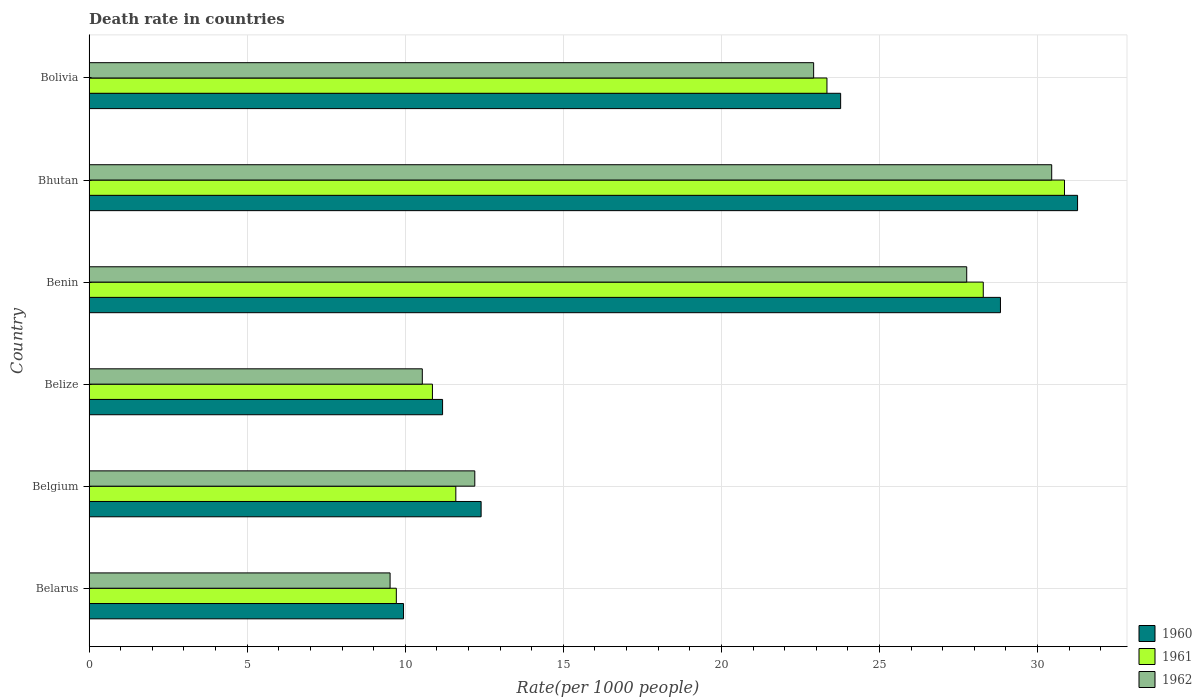How many different coloured bars are there?
Keep it short and to the point. 3. How many groups of bars are there?
Ensure brevity in your answer.  6. How many bars are there on the 6th tick from the bottom?
Your answer should be compact. 3. What is the label of the 5th group of bars from the top?
Offer a very short reply. Belgium. What is the death rate in 1961 in Bhutan?
Keep it short and to the point. 30.85. Across all countries, what is the maximum death rate in 1961?
Your answer should be very brief. 30.85. Across all countries, what is the minimum death rate in 1961?
Give a very brief answer. 9.72. In which country was the death rate in 1960 maximum?
Your answer should be compact. Bhutan. In which country was the death rate in 1960 minimum?
Provide a short and direct response. Belarus. What is the total death rate in 1960 in the graph?
Keep it short and to the point. 117.39. What is the difference between the death rate in 1961 in Belize and that in Bolivia?
Keep it short and to the point. -12.48. What is the difference between the death rate in 1961 in Belize and the death rate in 1960 in Belgium?
Offer a very short reply. -1.54. What is the average death rate in 1961 per country?
Ensure brevity in your answer.  19.11. What is the difference between the death rate in 1960 and death rate in 1962 in Belgium?
Offer a terse response. 0.2. What is the ratio of the death rate in 1960 in Benin to that in Bolivia?
Keep it short and to the point. 1.21. Is the death rate in 1960 in Benin less than that in Bhutan?
Your answer should be very brief. Yes. What is the difference between the highest and the second highest death rate in 1962?
Ensure brevity in your answer.  2.69. What is the difference between the highest and the lowest death rate in 1960?
Your answer should be compact. 21.32. In how many countries, is the death rate in 1962 greater than the average death rate in 1962 taken over all countries?
Your answer should be compact. 3. What does the 1st bar from the top in Bhutan represents?
Make the answer very short. 1962. What does the 3rd bar from the bottom in Bolivia represents?
Provide a short and direct response. 1962. What is the difference between two consecutive major ticks on the X-axis?
Offer a very short reply. 5. Are the values on the major ticks of X-axis written in scientific E-notation?
Provide a succinct answer. No. Does the graph contain grids?
Make the answer very short. Yes. How many legend labels are there?
Your response must be concise. 3. What is the title of the graph?
Your answer should be very brief. Death rate in countries. What is the label or title of the X-axis?
Give a very brief answer. Rate(per 1000 people). What is the label or title of the Y-axis?
Provide a short and direct response. Country. What is the Rate(per 1000 people) in 1960 in Belarus?
Your answer should be compact. 9.95. What is the Rate(per 1000 people) in 1961 in Belarus?
Offer a terse response. 9.72. What is the Rate(per 1000 people) of 1962 in Belarus?
Provide a succinct answer. 9.52. What is the Rate(per 1000 people) of 1960 in Belgium?
Ensure brevity in your answer.  12.4. What is the Rate(per 1000 people) of 1962 in Belgium?
Your response must be concise. 12.2. What is the Rate(per 1000 people) of 1960 in Belize?
Your response must be concise. 11.18. What is the Rate(per 1000 people) in 1961 in Belize?
Ensure brevity in your answer.  10.86. What is the Rate(per 1000 people) in 1962 in Belize?
Provide a short and direct response. 10.54. What is the Rate(per 1000 people) of 1960 in Benin?
Offer a very short reply. 28.83. What is the Rate(per 1000 people) of 1961 in Benin?
Offer a terse response. 28.28. What is the Rate(per 1000 people) of 1962 in Benin?
Keep it short and to the point. 27.76. What is the Rate(per 1000 people) of 1960 in Bhutan?
Offer a very short reply. 31.27. What is the Rate(per 1000 people) of 1961 in Bhutan?
Provide a succinct answer. 30.85. What is the Rate(per 1000 people) in 1962 in Bhutan?
Give a very brief answer. 30.45. What is the Rate(per 1000 people) of 1960 in Bolivia?
Make the answer very short. 23.77. What is the Rate(per 1000 people) in 1961 in Bolivia?
Make the answer very short. 23.34. What is the Rate(per 1000 people) of 1962 in Bolivia?
Keep it short and to the point. 22.92. Across all countries, what is the maximum Rate(per 1000 people) in 1960?
Provide a succinct answer. 31.27. Across all countries, what is the maximum Rate(per 1000 people) in 1961?
Keep it short and to the point. 30.85. Across all countries, what is the maximum Rate(per 1000 people) of 1962?
Your answer should be very brief. 30.45. Across all countries, what is the minimum Rate(per 1000 people) of 1960?
Provide a short and direct response. 9.95. Across all countries, what is the minimum Rate(per 1000 people) in 1961?
Provide a succinct answer. 9.72. Across all countries, what is the minimum Rate(per 1000 people) in 1962?
Provide a succinct answer. 9.52. What is the total Rate(per 1000 people) in 1960 in the graph?
Give a very brief answer. 117.39. What is the total Rate(per 1000 people) of 1961 in the graph?
Make the answer very short. 114.65. What is the total Rate(per 1000 people) of 1962 in the graph?
Ensure brevity in your answer.  113.39. What is the difference between the Rate(per 1000 people) of 1960 in Belarus and that in Belgium?
Your response must be concise. -2.45. What is the difference between the Rate(per 1000 people) in 1961 in Belarus and that in Belgium?
Keep it short and to the point. -1.88. What is the difference between the Rate(per 1000 people) of 1962 in Belarus and that in Belgium?
Provide a short and direct response. -2.68. What is the difference between the Rate(per 1000 people) of 1960 in Belarus and that in Belize?
Your answer should be compact. -1.24. What is the difference between the Rate(per 1000 people) of 1961 in Belarus and that in Belize?
Make the answer very short. -1.14. What is the difference between the Rate(per 1000 people) of 1962 in Belarus and that in Belize?
Give a very brief answer. -1.02. What is the difference between the Rate(per 1000 people) of 1960 in Belarus and that in Benin?
Keep it short and to the point. -18.88. What is the difference between the Rate(per 1000 people) of 1961 in Belarus and that in Benin?
Your response must be concise. -18.57. What is the difference between the Rate(per 1000 people) in 1962 in Belarus and that in Benin?
Your answer should be compact. -18.24. What is the difference between the Rate(per 1000 people) of 1960 in Belarus and that in Bhutan?
Keep it short and to the point. -21.32. What is the difference between the Rate(per 1000 people) in 1961 in Belarus and that in Bhutan?
Offer a very short reply. -21.13. What is the difference between the Rate(per 1000 people) of 1962 in Belarus and that in Bhutan?
Provide a short and direct response. -20.93. What is the difference between the Rate(per 1000 people) in 1960 in Belarus and that in Bolivia?
Provide a short and direct response. -13.83. What is the difference between the Rate(per 1000 people) in 1961 in Belarus and that in Bolivia?
Provide a succinct answer. -13.62. What is the difference between the Rate(per 1000 people) of 1962 in Belarus and that in Bolivia?
Provide a succinct answer. -13.4. What is the difference between the Rate(per 1000 people) of 1960 in Belgium and that in Belize?
Provide a succinct answer. 1.22. What is the difference between the Rate(per 1000 people) in 1961 in Belgium and that in Belize?
Your answer should be very brief. 0.74. What is the difference between the Rate(per 1000 people) of 1962 in Belgium and that in Belize?
Ensure brevity in your answer.  1.66. What is the difference between the Rate(per 1000 people) of 1960 in Belgium and that in Benin?
Offer a terse response. -16.43. What is the difference between the Rate(per 1000 people) of 1961 in Belgium and that in Benin?
Ensure brevity in your answer.  -16.68. What is the difference between the Rate(per 1000 people) of 1962 in Belgium and that in Benin?
Your response must be concise. -15.56. What is the difference between the Rate(per 1000 people) of 1960 in Belgium and that in Bhutan?
Your answer should be very brief. -18.87. What is the difference between the Rate(per 1000 people) of 1961 in Belgium and that in Bhutan?
Provide a short and direct response. -19.25. What is the difference between the Rate(per 1000 people) in 1962 in Belgium and that in Bhutan?
Make the answer very short. -18.25. What is the difference between the Rate(per 1000 people) of 1960 in Belgium and that in Bolivia?
Your answer should be very brief. -11.37. What is the difference between the Rate(per 1000 people) in 1961 in Belgium and that in Bolivia?
Offer a terse response. -11.74. What is the difference between the Rate(per 1000 people) in 1962 in Belgium and that in Bolivia?
Offer a terse response. -10.72. What is the difference between the Rate(per 1000 people) of 1960 in Belize and that in Benin?
Give a very brief answer. -17.65. What is the difference between the Rate(per 1000 people) in 1961 in Belize and that in Benin?
Provide a succinct answer. -17.42. What is the difference between the Rate(per 1000 people) in 1962 in Belize and that in Benin?
Your response must be concise. -17.22. What is the difference between the Rate(per 1000 people) in 1960 in Belize and that in Bhutan?
Provide a succinct answer. -20.09. What is the difference between the Rate(per 1000 people) in 1961 in Belize and that in Bhutan?
Give a very brief answer. -19.99. What is the difference between the Rate(per 1000 people) of 1962 in Belize and that in Bhutan?
Provide a short and direct response. -19.91. What is the difference between the Rate(per 1000 people) of 1960 in Belize and that in Bolivia?
Give a very brief answer. -12.59. What is the difference between the Rate(per 1000 people) in 1961 in Belize and that in Bolivia?
Provide a short and direct response. -12.48. What is the difference between the Rate(per 1000 people) of 1962 in Belize and that in Bolivia?
Your response must be concise. -12.38. What is the difference between the Rate(per 1000 people) of 1960 in Benin and that in Bhutan?
Your answer should be compact. -2.44. What is the difference between the Rate(per 1000 people) in 1961 in Benin and that in Bhutan?
Your response must be concise. -2.57. What is the difference between the Rate(per 1000 people) in 1962 in Benin and that in Bhutan?
Provide a short and direct response. -2.69. What is the difference between the Rate(per 1000 people) in 1960 in Benin and that in Bolivia?
Give a very brief answer. 5.05. What is the difference between the Rate(per 1000 people) in 1961 in Benin and that in Bolivia?
Your answer should be compact. 4.94. What is the difference between the Rate(per 1000 people) in 1962 in Benin and that in Bolivia?
Provide a short and direct response. 4.84. What is the difference between the Rate(per 1000 people) of 1960 in Bhutan and that in Bolivia?
Keep it short and to the point. 7.49. What is the difference between the Rate(per 1000 people) of 1961 in Bhutan and that in Bolivia?
Your answer should be compact. 7.51. What is the difference between the Rate(per 1000 people) of 1962 in Bhutan and that in Bolivia?
Make the answer very short. 7.53. What is the difference between the Rate(per 1000 people) in 1960 in Belarus and the Rate(per 1000 people) in 1961 in Belgium?
Provide a succinct answer. -1.65. What is the difference between the Rate(per 1000 people) in 1960 in Belarus and the Rate(per 1000 people) in 1962 in Belgium?
Offer a terse response. -2.25. What is the difference between the Rate(per 1000 people) in 1961 in Belarus and the Rate(per 1000 people) in 1962 in Belgium?
Offer a very short reply. -2.48. What is the difference between the Rate(per 1000 people) in 1960 in Belarus and the Rate(per 1000 people) in 1961 in Belize?
Your answer should be very brief. -0.91. What is the difference between the Rate(per 1000 people) in 1960 in Belarus and the Rate(per 1000 people) in 1962 in Belize?
Offer a terse response. -0.59. What is the difference between the Rate(per 1000 people) in 1961 in Belarus and the Rate(per 1000 people) in 1962 in Belize?
Your answer should be very brief. -0.82. What is the difference between the Rate(per 1000 people) in 1960 in Belarus and the Rate(per 1000 people) in 1961 in Benin?
Ensure brevity in your answer.  -18.34. What is the difference between the Rate(per 1000 people) of 1960 in Belarus and the Rate(per 1000 people) of 1962 in Benin?
Ensure brevity in your answer.  -17.81. What is the difference between the Rate(per 1000 people) in 1961 in Belarus and the Rate(per 1000 people) in 1962 in Benin?
Provide a short and direct response. -18.04. What is the difference between the Rate(per 1000 people) of 1960 in Belarus and the Rate(per 1000 people) of 1961 in Bhutan?
Your answer should be very brief. -20.91. What is the difference between the Rate(per 1000 people) of 1960 in Belarus and the Rate(per 1000 people) of 1962 in Bhutan?
Your answer should be compact. -20.5. What is the difference between the Rate(per 1000 people) in 1961 in Belarus and the Rate(per 1000 people) in 1962 in Bhutan?
Provide a short and direct response. -20.73. What is the difference between the Rate(per 1000 people) in 1960 in Belarus and the Rate(per 1000 people) in 1961 in Bolivia?
Keep it short and to the point. -13.39. What is the difference between the Rate(per 1000 people) of 1960 in Belarus and the Rate(per 1000 people) of 1962 in Bolivia?
Provide a succinct answer. -12.97. What is the difference between the Rate(per 1000 people) of 1960 in Belgium and the Rate(per 1000 people) of 1961 in Belize?
Provide a short and direct response. 1.54. What is the difference between the Rate(per 1000 people) in 1960 in Belgium and the Rate(per 1000 people) in 1962 in Belize?
Keep it short and to the point. 1.86. What is the difference between the Rate(per 1000 people) of 1961 in Belgium and the Rate(per 1000 people) of 1962 in Belize?
Your answer should be compact. 1.06. What is the difference between the Rate(per 1000 people) in 1960 in Belgium and the Rate(per 1000 people) in 1961 in Benin?
Your answer should be compact. -15.88. What is the difference between the Rate(per 1000 people) in 1960 in Belgium and the Rate(per 1000 people) in 1962 in Benin?
Your answer should be compact. -15.36. What is the difference between the Rate(per 1000 people) of 1961 in Belgium and the Rate(per 1000 people) of 1962 in Benin?
Ensure brevity in your answer.  -16.16. What is the difference between the Rate(per 1000 people) in 1960 in Belgium and the Rate(per 1000 people) in 1961 in Bhutan?
Offer a very short reply. -18.45. What is the difference between the Rate(per 1000 people) of 1960 in Belgium and the Rate(per 1000 people) of 1962 in Bhutan?
Your response must be concise. -18.05. What is the difference between the Rate(per 1000 people) of 1961 in Belgium and the Rate(per 1000 people) of 1962 in Bhutan?
Your answer should be very brief. -18.85. What is the difference between the Rate(per 1000 people) in 1960 in Belgium and the Rate(per 1000 people) in 1961 in Bolivia?
Provide a succinct answer. -10.94. What is the difference between the Rate(per 1000 people) in 1960 in Belgium and the Rate(per 1000 people) in 1962 in Bolivia?
Keep it short and to the point. -10.52. What is the difference between the Rate(per 1000 people) in 1961 in Belgium and the Rate(per 1000 people) in 1962 in Bolivia?
Offer a very short reply. -11.32. What is the difference between the Rate(per 1000 people) in 1960 in Belize and the Rate(per 1000 people) in 1961 in Benin?
Provide a short and direct response. -17.1. What is the difference between the Rate(per 1000 people) of 1960 in Belize and the Rate(per 1000 people) of 1962 in Benin?
Give a very brief answer. -16.58. What is the difference between the Rate(per 1000 people) in 1961 in Belize and the Rate(per 1000 people) in 1962 in Benin?
Make the answer very short. -16.9. What is the difference between the Rate(per 1000 people) in 1960 in Belize and the Rate(per 1000 people) in 1961 in Bhutan?
Your response must be concise. -19.67. What is the difference between the Rate(per 1000 people) in 1960 in Belize and the Rate(per 1000 people) in 1962 in Bhutan?
Your answer should be compact. -19.27. What is the difference between the Rate(per 1000 people) in 1961 in Belize and the Rate(per 1000 people) in 1962 in Bhutan?
Your answer should be very brief. -19.59. What is the difference between the Rate(per 1000 people) in 1960 in Belize and the Rate(per 1000 people) in 1961 in Bolivia?
Provide a short and direct response. -12.16. What is the difference between the Rate(per 1000 people) in 1960 in Belize and the Rate(per 1000 people) in 1962 in Bolivia?
Offer a terse response. -11.74. What is the difference between the Rate(per 1000 people) of 1961 in Belize and the Rate(per 1000 people) of 1962 in Bolivia?
Ensure brevity in your answer.  -12.06. What is the difference between the Rate(per 1000 people) of 1960 in Benin and the Rate(per 1000 people) of 1961 in Bhutan?
Provide a short and direct response. -2.02. What is the difference between the Rate(per 1000 people) in 1960 in Benin and the Rate(per 1000 people) in 1962 in Bhutan?
Make the answer very short. -1.62. What is the difference between the Rate(per 1000 people) of 1961 in Benin and the Rate(per 1000 people) of 1962 in Bhutan?
Offer a terse response. -2.17. What is the difference between the Rate(per 1000 people) in 1960 in Benin and the Rate(per 1000 people) in 1961 in Bolivia?
Offer a very short reply. 5.49. What is the difference between the Rate(per 1000 people) in 1960 in Benin and the Rate(per 1000 people) in 1962 in Bolivia?
Ensure brevity in your answer.  5.91. What is the difference between the Rate(per 1000 people) of 1961 in Benin and the Rate(per 1000 people) of 1962 in Bolivia?
Offer a very short reply. 5.37. What is the difference between the Rate(per 1000 people) in 1960 in Bhutan and the Rate(per 1000 people) in 1961 in Bolivia?
Provide a short and direct response. 7.93. What is the difference between the Rate(per 1000 people) in 1960 in Bhutan and the Rate(per 1000 people) in 1962 in Bolivia?
Make the answer very short. 8.35. What is the difference between the Rate(per 1000 people) in 1961 in Bhutan and the Rate(per 1000 people) in 1962 in Bolivia?
Ensure brevity in your answer.  7.93. What is the average Rate(per 1000 people) in 1960 per country?
Offer a terse response. 19.57. What is the average Rate(per 1000 people) of 1961 per country?
Provide a succinct answer. 19.11. What is the average Rate(per 1000 people) of 1962 per country?
Make the answer very short. 18.9. What is the difference between the Rate(per 1000 people) of 1960 and Rate(per 1000 people) of 1961 in Belarus?
Provide a succinct answer. 0.23. What is the difference between the Rate(per 1000 people) in 1960 and Rate(per 1000 people) in 1962 in Belarus?
Offer a very short reply. 0.42. What is the difference between the Rate(per 1000 people) in 1961 and Rate(per 1000 people) in 1962 in Belarus?
Your response must be concise. 0.2. What is the difference between the Rate(per 1000 people) in 1960 and Rate(per 1000 people) in 1962 in Belgium?
Give a very brief answer. 0.2. What is the difference between the Rate(per 1000 people) in 1960 and Rate(per 1000 people) in 1961 in Belize?
Keep it short and to the point. 0.32. What is the difference between the Rate(per 1000 people) of 1960 and Rate(per 1000 people) of 1962 in Belize?
Ensure brevity in your answer.  0.64. What is the difference between the Rate(per 1000 people) in 1961 and Rate(per 1000 people) in 1962 in Belize?
Your response must be concise. 0.32. What is the difference between the Rate(per 1000 people) in 1960 and Rate(per 1000 people) in 1961 in Benin?
Your answer should be compact. 0.54. What is the difference between the Rate(per 1000 people) of 1960 and Rate(per 1000 people) of 1962 in Benin?
Keep it short and to the point. 1.07. What is the difference between the Rate(per 1000 people) in 1961 and Rate(per 1000 people) in 1962 in Benin?
Your answer should be very brief. 0.52. What is the difference between the Rate(per 1000 people) in 1960 and Rate(per 1000 people) in 1961 in Bhutan?
Make the answer very short. 0.41. What is the difference between the Rate(per 1000 people) of 1960 and Rate(per 1000 people) of 1962 in Bhutan?
Your answer should be compact. 0.82. What is the difference between the Rate(per 1000 people) in 1961 and Rate(per 1000 people) in 1962 in Bhutan?
Offer a very short reply. 0.4. What is the difference between the Rate(per 1000 people) in 1960 and Rate(per 1000 people) in 1961 in Bolivia?
Offer a very short reply. 0.43. What is the difference between the Rate(per 1000 people) of 1960 and Rate(per 1000 people) of 1962 in Bolivia?
Provide a short and direct response. 0.85. What is the difference between the Rate(per 1000 people) in 1961 and Rate(per 1000 people) in 1962 in Bolivia?
Offer a very short reply. 0.42. What is the ratio of the Rate(per 1000 people) of 1960 in Belarus to that in Belgium?
Keep it short and to the point. 0.8. What is the ratio of the Rate(per 1000 people) in 1961 in Belarus to that in Belgium?
Make the answer very short. 0.84. What is the ratio of the Rate(per 1000 people) of 1962 in Belarus to that in Belgium?
Your response must be concise. 0.78. What is the ratio of the Rate(per 1000 people) of 1960 in Belarus to that in Belize?
Your answer should be compact. 0.89. What is the ratio of the Rate(per 1000 people) in 1961 in Belarus to that in Belize?
Provide a short and direct response. 0.89. What is the ratio of the Rate(per 1000 people) in 1962 in Belarus to that in Belize?
Offer a terse response. 0.9. What is the ratio of the Rate(per 1000 people) of 1960 in Belarus to that in Benin?
Your answer should be compact. 0.34. What is the ratio of the Rate(per 1000 people) of 1961 in Belarus to that in Benin?
Ensure brevity in your answer.  0.34. What is the ratio of the Rate(per 1000 people) in 1962 in Belarus to that in Benin?
Ensure brevity in your answer.  0.34. What is the ratio of the Rate(per 1000 people) of 1960 in Belarus to that in Bhutan?
Provide a short and direct response. 0.32. What is the ratio of the Rate(per 1000 people) of 1961 in Belarus to that in Bhutan?
Ensure brevity in your answer.  0.32. What is the ratio of the Rate(per 1000 people) in 1962 in Belarus to that in Bhutan?
Offer a very short reply. 0.31. What is the ratio of the Rate(per 1000 people) of 1960 in Belarus to that in Bolivia?
Keep it short and to the point. 0.42. What is the ratio of the Rate(per 1000 people) in 1961 in Belarus to that in Bolivia?
Make the answer very short. 0.42. What is the ratio of the Rate(per 1000 people) of 1962 in Belarus to that in Bolivia?
Your response must be concise. 0.42. What is the ratio of the Rate(per 1000 people) of 1960 in Belgium to that in Belize?
Give a very brief answer. 1.11. What is the ratio of the Rate(per 1000 people) in 1961 in Belgium to that in Belize?
Give a very brief answer. 1.07. What is the ratio of the Rate(per 1000 people) of 1962 in Belgium to that in Belize?
Offer a very short reply. 1.16. What is the ratio of the Rate(per 1000 people) in 1960 in Belgium to that in Benin?
Provide a short and direct response. 0.43. What is the ratio of the Rate(per 1000 people) in 1961 in Belgium to that in Benin?
Provide a succinct answer. 0.41. What is the ratio of the Rate(per 1000 people) in 1962 in Belgium to that in Benin?
Offer a very short reply. 0.44. What is the ratio of the Rate(per 1000 people) of 1960 in Belgium to that in Bhutan?
Your answer should be very brief. 0.4. What is the ratio of the Rate(per 1000 people) of 1961 in Belgium to that in Bhutan?
Your answer should be very brief. 0.38. What is the ratio of the Rate(per 1000 people) in 1962 in Belgium to that in Bhutan?
Give a very brief answer. 0.4. What is the ratio of the Rate(per 1000 people) in 1960 in Belgium to that in Bolivia?
Offer a very short reply. 0.52. What is the ratio of the Rate(per 1000 people) of 1961 in Belgium to that in Bolivia?
Make the answer very short. 0.5. What is the ratio of the Rate(per 1000 people) in 1962 in Belgium to that in Bolivia?
Ensure brevity in your answer.  0.53. What is the ratio of the Rate(per 1000 people) in 1960 in Belize to that in Benin?
Offer a terse response. 0.39. What is the ratio of the Rate(per 1000 people) in 1961 in Belize to that in Benin?
Offer a very short reply. 0.38. What is the ratio of the Rate(per 1000 people) in 1962 in Belize to that in Benin?
Make the answer very short. 0.38. What is the ratio of the Rate(per 1000 people) in 1960 in Belize to that in Bhutan?
Make the answer very short. 0.36. What is the ratio of the Rate(per 1000 people) in 1961 in Belize to that in Bhutan?
Give a very brief answer. 0.35. What is the ratio of the Rate(per 1000 people) of 1962 in Belize to that in Bhutan?
Offer a terse response. 0.35. What is the ratio of the Rate(per 1000 people) in 1960 in Belize to that in Bolivia?
Give a very brief answer. 0.47. What is the ratio of the Rate(per 1000 people) in 1961 in Belize to that in Bolivia?
Your answer should be compact. 0.47. What is the ratio of the Rate(per 1000 people) of 1962 in Belize to that in Bolivia?
Ensure brevity in your answer.  0.46. What is the ratio of the Rate(per 1000 people) in 1960 in Benin to that in Bhutan?
Provide a short and direct response. 0.92. What is the ratio of the Rate(per 1000 people) of 1961 in Benin to that in Bhutan?
Keep it short and to the point. 0.92. What is the ratio of the Rate(per 1000 people) of 1962 in Benin to that in Bhutan?
Your answer should be very brief. 0.91. What is the ratio of the Rate(per 1000 people) of 1960 in Benin to that in Bolivia?
Give a very brief answer. 1.21. What is the ratio of the Rate(per 1000 people) of 1961 in Benin to that in Bolivia?
Your response must be concise. 1.21. What is the ratio of the Rate(per 1000 people) in 1962 in Benin to that in Bolivia?
Offer a very short reply. 1.21. What is the ratio of the Rate(per 1000 people) in 1960 in Bhutan to that in Bolivia?
Give a very brief answer. 1.32. What is the ratio of the Rate(per 1000 people) of 1961 in Bhutan to that in Bolivia?
Keep it short and to the point. 1.32. What is the ratio of the Rate(per 1000 people) of 1962 in Bhutan to that in Bolivia?
Make the answer very short. 1.33. What is the difference between the highest and the second highest Rate(per 1000 people) of 1960?
Keep it short and to the point. 2.44. What is the difference between the highest and the second highest Rate(per 1000 people) of 1961?
Your answer should be very brief. 2.57. What is the difference between the highest and the second highest Rate(per 1000 people) in 1962?
Provide a succinct answer. 2.69. What is the difference between the highest and the lowest Rate(per 1000 people) of 1960?
Your response must be concise. 21.32. What is the difference between the highest and the lowest Rate(per 1000 people) of 1961?
Offer a terse response. 21.13. What is the difference between the highest and the lowest Rate(per 1000 people) of 1962?
Give a very brief answer. 20.93. 